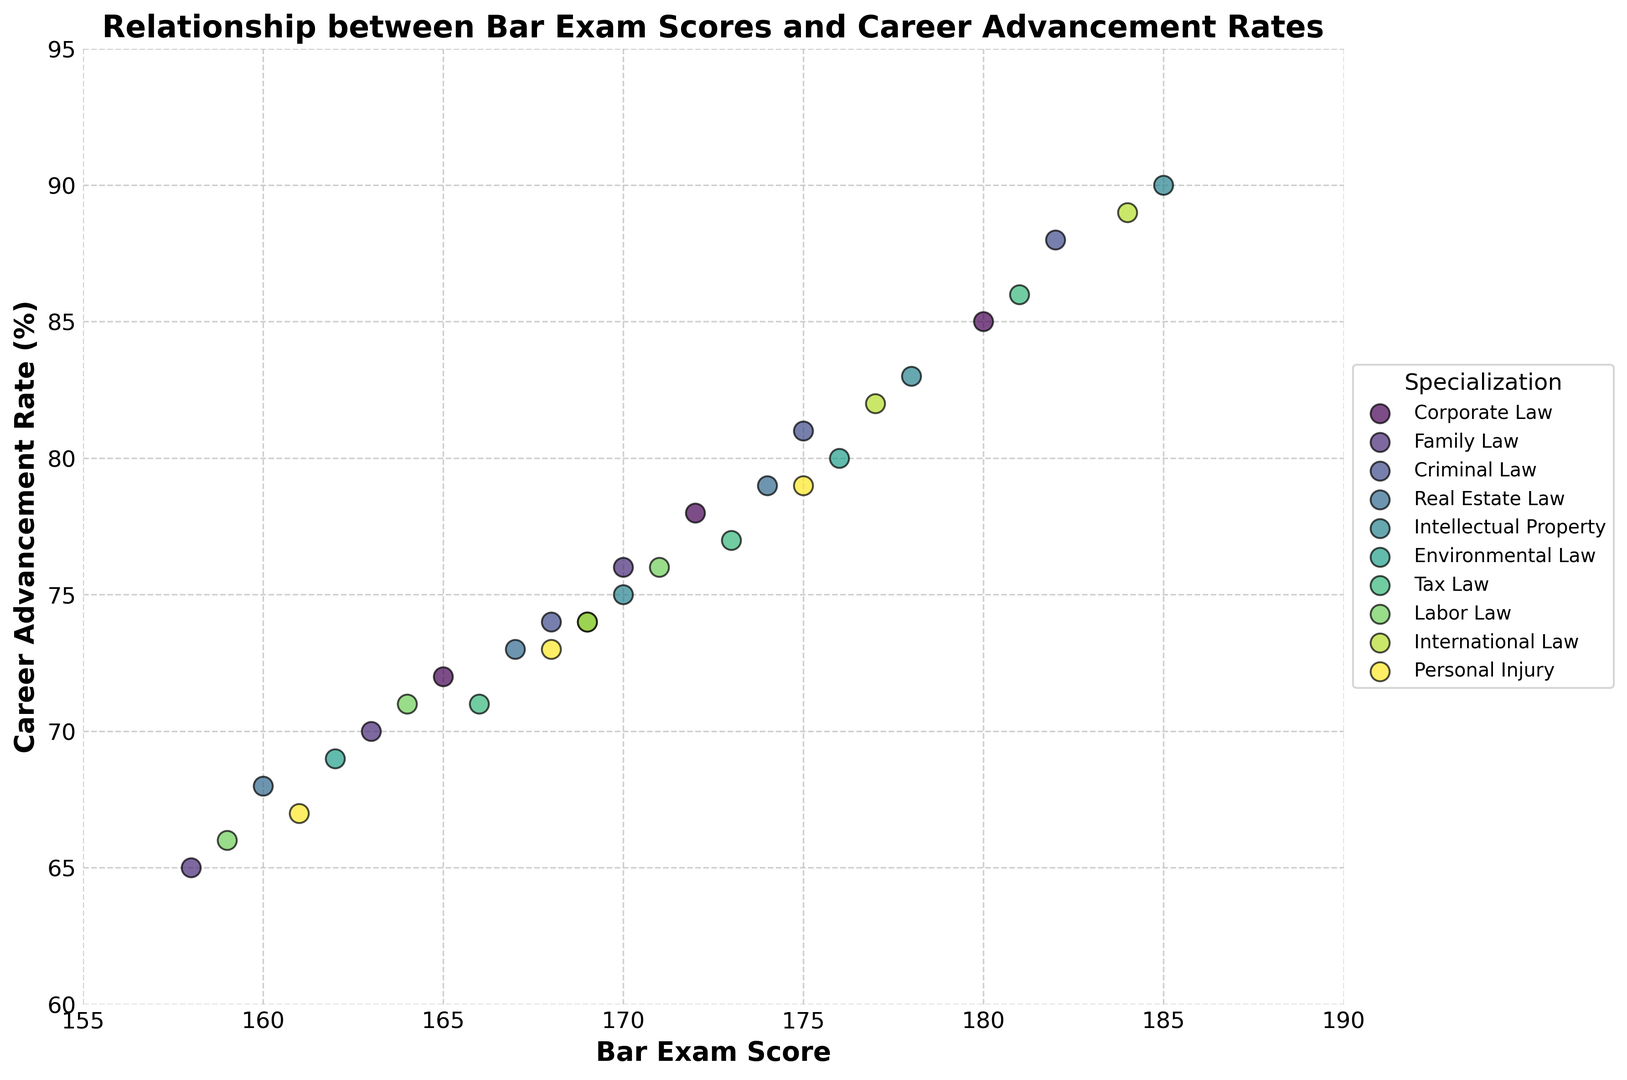Which specialization has the highest career advancement rate? In the figure, look for the specialization with the highest point on the y-axis which represents career advancement rate.
Answer: Intellectual Property Are there any specializations where the career advancement rate consistently increases with the bar exam score? Identify the trend within each specialization by observing if higher bar exam scores are associated with higher career advancement rates within the same colored points.
Answer: Yes, for specializations like Corporate Law, Criminal Law, and Intellectual Property, career advancement rates increase with the bar exam scores Which two specializations have the most similar career advancement rates for bar exam scores around 170? Find the data points around 170 on the x-axis and compare their positions on the y-axis to check for proximity.
Answer: Family Law and Intellectual Property Which specialization shows the widest range of career advancement rates? Identify the specialization with the greatest vertical spread of points on the y-axis.
Answer: Criminal Law Visualizing corporate law, how much does the career advancement rate increase from a bar exam score of 165 to 180? Subtract the career advancement rate at 165 (72%) from the rate at 180 (85%).
Answer: 13% Among the specializations, which one shows the highest career advancement rate for the lowest bar exam score observed? Locate the lowest bar exam score on the x-axis and identify which specialization's point on the y-axis is the highest.
Answer: Criminal Law For bar exam scores in the range 175–185, which specialization shows the largest variation in career advancement rates? Observing the points between 175 and 185 on the x-axis, identify the specialization with the highest spread of y-values.
Answer: International Law Do any specializations have overlapping career advancement rates for different bar exam scores? Check if there are career advancement rates that are similar across different specializations for given bar exam scores by overlapping points.
Answer: Yes, for bar exam scores like 170, different specializations like Family Law and Real Estate Law overlap in career advancement rates Which specialization has the lowest career advancement rate for bar exam score 167? Find the data point corresponding to a bar exam score of 167 and determine the lowest y-coordinate (career advancement rate) among them.
Answer: Real Estate Law How many specializations show a career advancement rate above 80% for any bar exam score? Identify all specializations that have at least one data point with a career advancement rate above 80% on the y-axis.
Answer: Six 